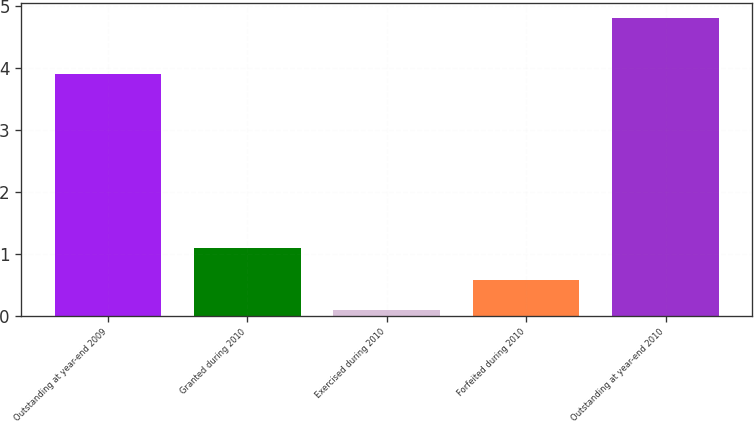<chart> <loc_0><loc_0><loc_500><loc_500><bar_chart><fcel>Outstanding at year-end 2009<fcel>Granted during 2010<fcel>Exercised during 2010<fcel>Forfeited during 2010<fcel>Outstanding at year-end 2010<nl><fcel>3.9<fcel>1.1<fcel>0.1<fcel>0.57<fcel>4.8<nl></chart> 